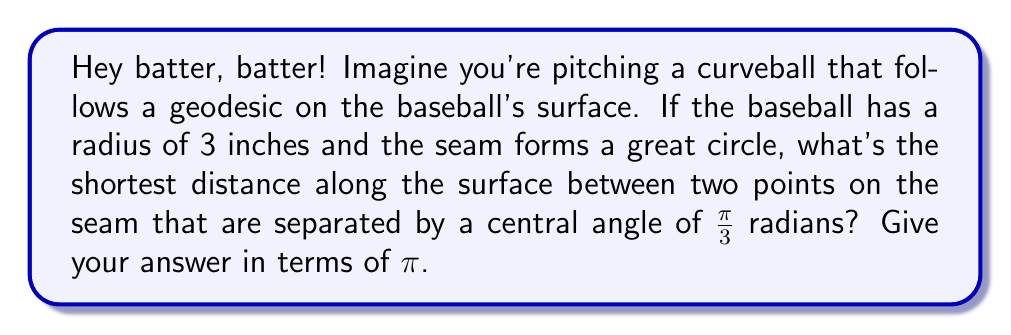Provide a solution to this math problem. Alright, let's break this down step-by-step:

1) First, recall that on a sphere, the geodesics (shortest paths) are great circles. The seam of a baseball forms a great circle, so we're already on the right track!

2) The formula for the arc length $s$ of a great circle on a sphere is:

   $$s = r\theta$$

   where $r$ is the radius of the sphere and $\theta$ is the central angle in radians.

3) We're given that:
   - The radius of the baseball $r = 3$ inches
   - The central angle $\theta = \frac{\pi}{3}$ radians

4) Let's plug these values into our formula:

   $$s = 3 \cdot \frac{\pi}{3}$$

5) Simplify:

   $$s = \pi$$ inches

6) The question asks for the answer in terms of $\pi$, so we're done!

This shows that the shortest distance along the surface between the two points is exactly $\pi$ inches, or one-third of the baseball's circumference. Pretty cool, huh? Just like how you need to understand the curve of the ball to hit it out of the park!
Answer: $\pi$ inches 